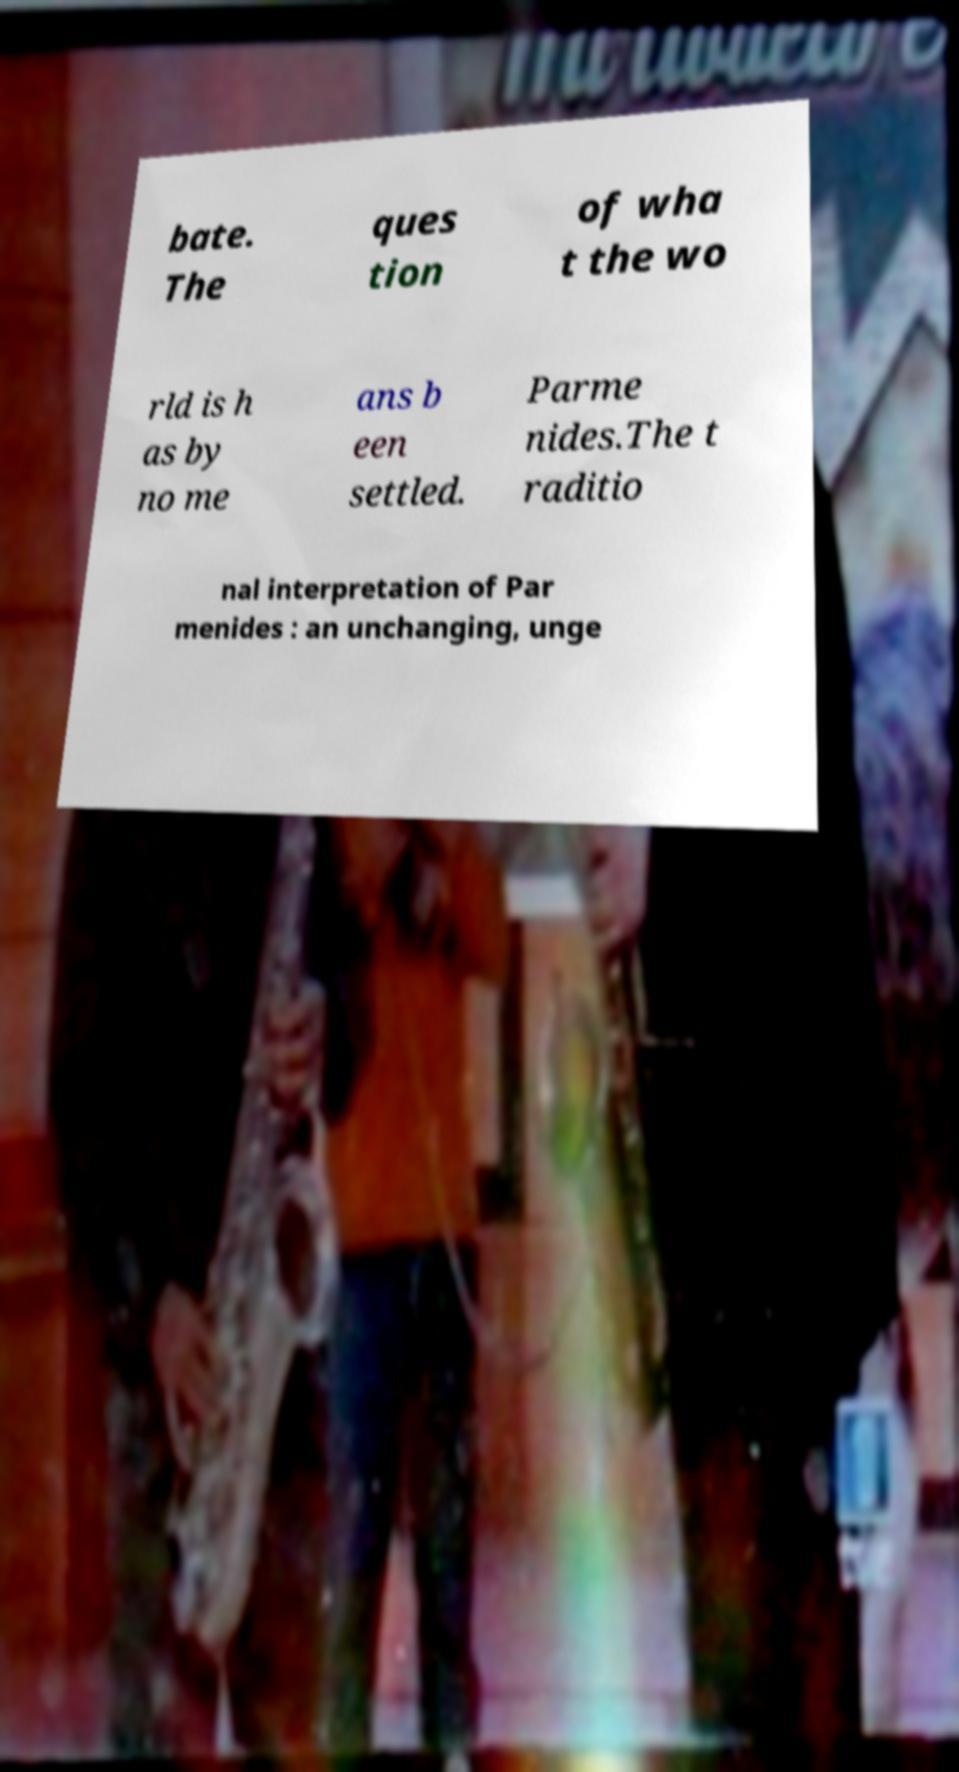For documentation purposes, I need the text within this image transcribed. Could you provide that? bate. The ques tion of wha t the wo rld is h as by no me ans b een settled. Parme nides.The t raditio nal interpretation of Par menides : an unchanging, unge 